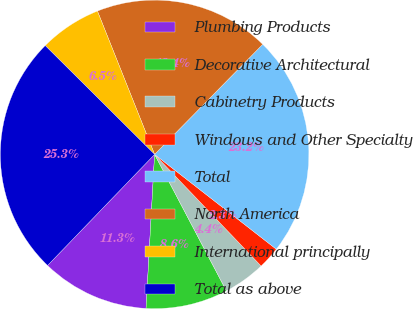Convert chart. <chart><loc_0><loc_0><loc_500><loc_500><pie_chart><fcel>Plumbing Products<fcel>Decorative Architectural<fcel>Cabinetry Products<fcel>Windows and Other Specialty<fcel>Total<fcel>North America<fcel>International principally<fcel>Total as above<nl><fcel>11.32%<fcel>8.59%<fcel>4.42%<fcel>2.34%<fcel>23.18%<fcel>18.4%<fcel>6.5%<fcel>25.26%<nl></chart> 